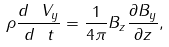Convert formula to latex. <formula><loc_0><loc_0><loc_500><loc_500>\rho \frac { d \ V _ { y } } { d \ t } = \frac { 1 } { 4 \pi } B _ { z } \frac { \partial B _ { y } } { \partial z } ,</formula> 